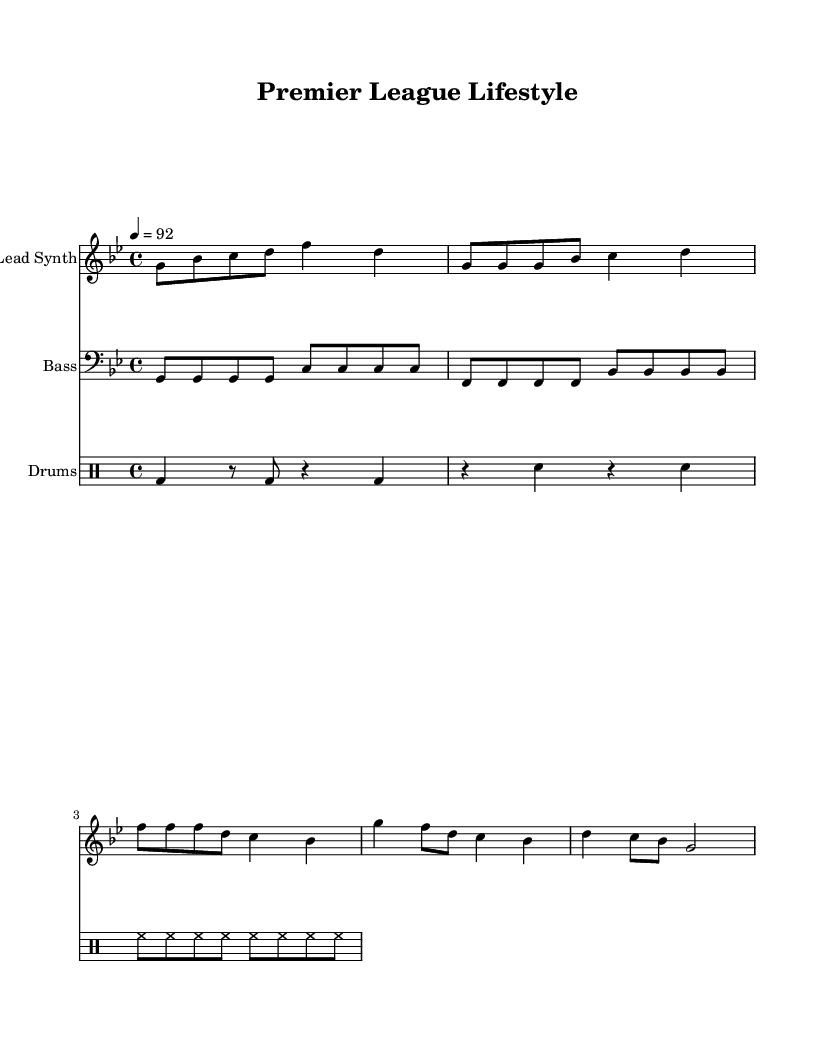What is the key signature of this music? The key signature is G minor, which has two flats (B♭ and E♭). This can be identified by looking at the key signature section at the beginning of the music.
Answer: G minor What is the time signature of this piece? The time signature is 4/4, meaning there are four beats in each measure, and each quarter note receives one beat. This can be seen at the beginning of the score.
Answer: 4/4 What is the tempo marking for the music? The tempo marking is 92 beats per minute (bpm), which indicates the speed of the piece. This is stated as "4 = 92" which means the quarter note gets 92 beats per minute.
Answer: 92 How many measures are in the chorus section of the music? The chorus section, marked with the lyrics that correspond to the lead synth, consists of 4 measures. This is determined by counting the bar lines in the segment that features the chorus lyrics.
Answer: 4 What lifestyle does the rap lyrics portray? The rap lyrics portray a luxurious lifestyle associated with the Premier League, mentioning luxury cars and a champagne lifestyle. This is derived from analyzing the lyrics included beneath the music notation.
Answer: Luxurious How does the drum pattern in the score contribute to the rap style? The drum pattern consists of a kick drum, snare, and hi-hat, creating a strong rhythmic foundation typical of rap music, which emphasizes the beat and complements the flow of the lyrics. By analyzing the drumming notation, one can see how the elements combine to create a driving feel.
Answer: Strong rhythmic foundation What is represented by the lead synth line in the context of hip-hop? The lead synth line creates a catchy melody that is often used to hook listeners in hip-hop tracks, drawing attention and complementing the lyrical content. This can be understood by recognizing how lead synths function in rap music as melodic support.
Answer: Catchy melody 